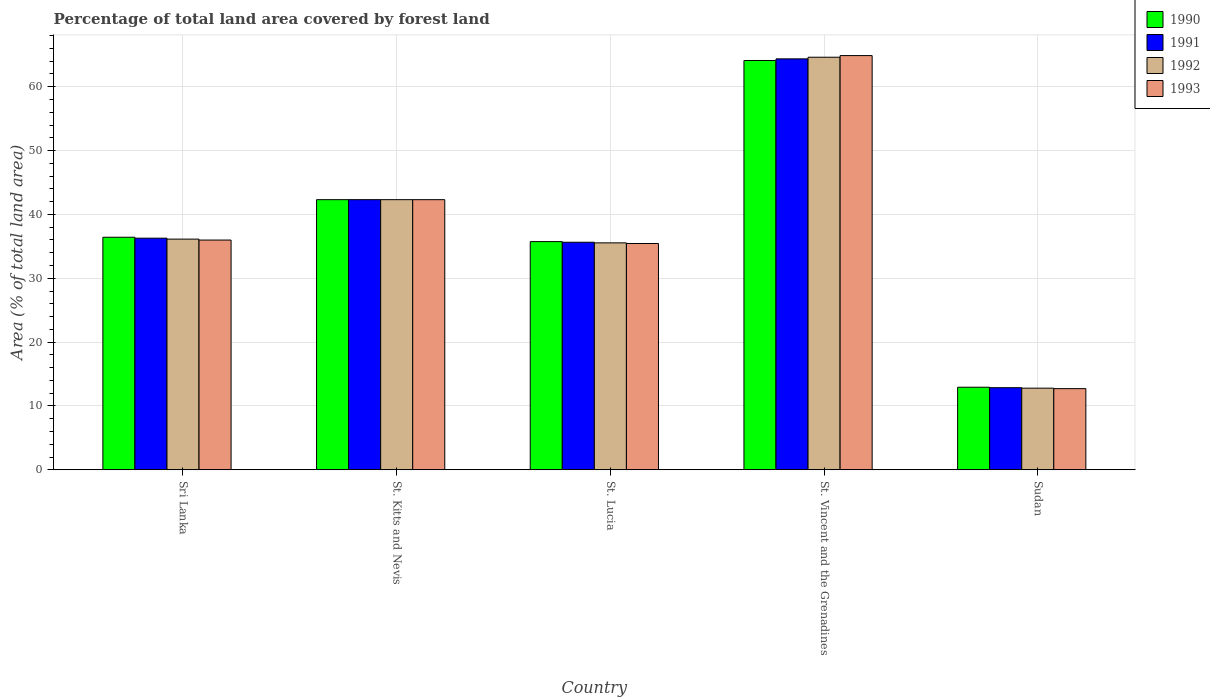How many different coloured bars are there?
Provide a short and direct response. 4. How many groups of bars are there?
Offer a very short reply. 5. What is the label of the 2nd group of bars from the left?
Provide a short and direct response. St. Kitts and Nevis. What is the percentage of forest land in 1992 in Sudan?
Ensure brevity in your answer.  12.79. Across all countries, what is the maximum percentage of forest land in 1991?
Provide a succinct answer. 64.36. Across all countries, what is the minimum percentage of forest land in 1992?
Your answer should be very brief. 12.79. In which country was the percentage of forest land in 1991 maximum?
Offer a very short reply. St. Vincent and the Grenadines. In which country was the percentage of forest land in 1990 minimum?
Offer a terse response. Sudan. What is the total percentage of forest land in 1993 in the graph?
Ensure brevity in your answer.  191.32. What is the difference between the percentage of forest land in 1991 in St. Lucia and that in Sudan?
Provide a short and direct response. 22.78. What is the difference between the percentage of forest land in 1992 in Sri Lanka and the percentage of forest land in 1993 in St. Kitts and Nevis?
Provide a succinct answer. -6.18. What is the average percentage of forest land in 1992 per country?
Make the answer very short. 38.28. What is the difference between the percentage of forest land of/in 1992 and percentage of forest land of/in 1991 in Sri Lanka?
Offer a very short reply. -0.15. In how many countries, is the percentage of forest land in 1990 greater than 56 %?
Ensure brevity in your answer.  1. What is the ratio of the percentage of forest land in 1992 in St. Vincent and the Grenadines to that in Sudan?
Keep it short and to the point. 5.05. Is the percentage of forest land in 1992 in St. Kitts and Nevis less than that in Sudan?
Keep it short and to the point. No. What is the difference between the highest and the second highest percentage of forest land in 1992?
Offer a very short reply. 22.31. What is the difference between the highest and the lowest percentage of forest land in 1992?
Provide a short and direct response. 51.83. In how many countries, is the percentage of forest land in 1991 greater than the average percentage of forest land in 1991 taken over all countries?
Ensure brevity in your answer.  2. Is it the case that in every country, the sum of the percentage of forest land in 1993 and percentage of forest land in 1992 is greater than the sum of percentage of forest land in 1990 and percentage of forest land in 1991?
Your answer should be compact. No. What does the 3rd bar from the left in Sudan represents?
Keep it short and to the point. 1992. What does the 2nd bar from the right in St. Lucia represents?
Your answer should be very brief. 1992. Is it the case that in every country, the sum of the percentage of forest land in 1991 and percentage of forest land in 1990 is greater than the percentage of forest land in 1993?
Keep it short and to the point. Yes. How many bars are there?
Offer a terse response. 20. Are all the bars in the graph horizontal?
Offer a terse response. No. Are the values on the major ticks of Y-axis written in scientific E-notation?
Your answer should be compact. No. Does the graph contain any zero values?
Offer a very short reply. No. Where does the legend appear in the graph?
Keep it short and to the point. Top right. How are the legend labels stacked?
Make the answer very short. Vertical. What is the title of the graph?
Provide a short and direct response. Percentage of total land area covered by forest land. What is the label or title of the Y-axis?
Your response must be concise. Area (% of total land area). What is the Area (% of total land area) in 1990 in Sri Lanka?
Your response must be concise. 36.42. What is the Area (% of total land area) in 1991 in Sri Lanka?
Give a very brief answer. 36.27. What is the Area (% of total land area) of 1992 in Sri Lanka?
Provide a succinct answer. 36.13. What is the Area (% of total land area) in 1993 in Sri Lanka?
Your answer should be compact. 35.98. What is the Area (% of total land area) in 1990 in St. Kitts and Nevis?
Offer a terse response. 42.31. What is the Area (% of total land area) of 1991 in St. Kitts and Nevis?
Ensure brevity in your answer.  42.31. What is the Area (% of total land area) in 1992 in St. Kitts and Nevis?
Provide a short and direct response. 42.31. What is the Area (% of total land area) in 1993 in St. Kitts and Nevis?
Provide a succinct answer. 42.31. What is the Area (% of total land area) in 1990 in St. Lucia?
Make the answer very short. 35.74. What is the Area (% of total land area) in 1991 in St. Lucia?
Make the answer very short. 35.64. What is the Area (% of total land area) of 1992 in St. Lucia?
Your answer should be compact. 35.54. What is the Area (% of total land area) in 1993 in St. Lucia?
Make the answer very short. 35.44. What is the Area (% of total land area) in 1990 in St. Vincent and the Grenadines?
Your response must be concise. 64.1. What is the Area (% of total land area) in 1991 in St. Vincent and the Grenadines?
Ensure brevity in your answer.  64.36. What is the Area (% of total land area) in 1992 in St. Vincent and the Grenadines?
Your response must be concise. 64.62. What is the Area (% of total land area) in 1993 in St. Vincent and the Grenadines?
Your answer should be very brief. 64.87. What is the Area (% of total land area) of 1990 in Sudan?
Provide a short and direct response. 12.93. What is the Area (% of total land area) in 1991 in Sudan?
Provide a succinct answer. 12.86. What is the Area (% of total land area) of 1992 in Sudan?
Give a very brief answer. 12.79. What is the Area (% of total land area) in 1993 in Sudan?
Offer a terse response. 12.71. Across all countries, what is the maximum Area (% of total land area) of 1990?
Your answer should be compact. 64.1. Across all countries, what is the maximum Area (% of total land area) in 1991?
Offer a very short reply. 64.36. Across all countries, what is the maximum Area (% of total land area) of 1992?
Keep it short and to the point. 64.62. Across all countries, what is the maximum Area (% of total land area) in 1993?
Ensure brevity in your answer.  64.87. Across all countries, what is the minimum Area (% of total land area) of 1990?
Offer a terse response. 12.93. Across all countries, what is the minimum Area (% of total land area) of 1991?
Provide a succinct answer. 12.86. Across all countries, what is the minimum Area (% of total land area) of 1992?
Your answer should be compact. 12.79. Across all countries, what is the minimum Area (% of total land area) of 1993?
Your answer should be compact. 12.71. What is the total Area (% of total land area) in 1990 in the graph?
Your answer should be very brief. 191.5. What is the total Area (% of total land area) in 1991 in the graph?
Your answer should be very brief. 191.44. What is the total Area (% of total land area) in 1992 in the graph?
Give a very brief answer. 191.38. What is the total Area (% of total land area) in 1993 in the graph?
Your answer should be compact. 191.32. What is the difference between the Area (% of total land area) of 1990 in Sri Lanka and that in St. Kitts and Nevis?
Keep it short and to the point. -5.89. What is the difference between the Area (% of total land area) of 1991 in Sri Lanka and that in St. Kitts and Nevis?
Your answer should be compact. -6.03. What is the difference between the Area (% of total land area) in 1992 in Sri Lanka and that in St. Kitts and Nevis?
Keep it short and to the point. -6.18. What is the difference between the Area (% of total land area) in 1993 in Sri Lanka and that in St. Kitts and Nevis?
Keep it short and to the point. -6.33. What is the difference between the Area (% of total land area) of 1990 in Sri Lanka and that in St. Lucia?
Ensure brevity in your answer.  0.68. What is the difference between the Area (% of total land area) of 1991 in Sri Lanka and that in St. Lucia?
Keep it short and to the point. 0.64. What is the difference between the Area (% of total land area) in 1992 in Sri Lanka and that in St. Lucia?
Your response must be concise. 0.59. What is the difference between the Area (% of total land area) in 1993 in Sri Lanka and that in St. Lucia?
Your answer should be very brief. 0.54. What is the difference between the Area (% of total land area) in 1990 in Sri Lanka and that in St. Vincent and the Grenadines?
Your response must be concise. -27.68. What is the difference between the Area (% of total land area) in 1991 in Sri Lanka and that in St. Vincent and the Grenadines?
Your answer should be very brief. -28.08. What is the difference between the Area (% of total land area) of 1992 in Sri Lanka and that in St. Vincent and the Grenadines?
Your answer should be compact. -28.49. What is the difference between the Area (% of total land area) in 1993 in Sri Lanka and that in St. Vincent and the Grenadines?
Give a very brief answer. -28.89. What is the difference between the Area (% of total land area) of 1990 in Sri Lanka and that in Sudan?
Your response must be concise. 23.49. What is the difference between the Area (% of total land area) of 1991 in Sri Lanka and that in Sudan?
Offer a very short reply. 23.42. What is the difference between the Area (% of total land area) in 1992 in Sri Lanka and that in Sudan?
Your answer should be very brief. 23.34. What is the difference between the Area (% of total land area) in 1993 in Sri Lanka and that in Sudan?
Offer a very short reply. 23.27. What is the difference between the Area (% of total land area) in 1990 in St. Kitts and Nevis and that in St. Lucia?
Your response must be concise. 6.57. What is the difference between the Area (% of total land area) in 1991 in St. Kitts and Nevis and that in St. Lucia?
Keep it short and to the point. 6.67. What is the difference between the Area (% of total land area) of 1992 in St. Kitts and Nevis and that in St. Lucia?
Provide a succinct answer. 6.77. What is the difference between the Area (% of total land area) in 1993 in St. Kitts and Nevis and that in St. Lucia?
Your response must be concise. 6.87. What is the difference between the Area (% of total land area) of 1990 in St. Kitts and Nevis and that in St. Vincent and the Grenadines?
Your response must be concise. -21.79. What is the difference between the Area (% of total land area) in 1991 in St. Kitts and Nevis and that in St. Vincent and the Grenadines?
Provide a short and direct response. -22.05. What is the difference between the Area (% of total land area) of 1992 in St. Kitts and Nevis and that in St. Vincent and the Grenadines?
Provide a short and direct response. -22.31. What is the difference between the Area (% of total land area) of 1993 in St. Kitts and Nevis and that in St. Vincent and the Grenadines?
Your answer should be very brief. -22.56. What is the difference between the Area (% of total land area) in 1990 in St. Kitts and Nevis and that in Sudan?
Your answer should be very brief. 29.38. What is the difference between the Area (% of total land area) in 1991 in St. Kitts and Nevis and that in Sudan?
Your answer should be compact. 29.45. What is the difference between the Area (% of total land area) of 1992 in St. Kitts and Nevis and that in Sudan?
Ensure brevity in your answer.  29.52. What is the difference between the Area (% of total land area) of 1993 in St. Kitts and Nevis and that in Sudan?
Ensure brevity in your answer.  29.6. What is the difference between the Area (% of total land area) in 1990 in St. Lucia and that in St. Vincent and the Grenadines?
Give a very brief answer. -28.36. What is the difference between the Area (% of total land area) in 1991 in St. Lucia and that in St. Vincent and the Grenadines?
Your answer should be compact. -28.72. What is the difference between the Area (% of total land area) of 1992 in St. Lucia and that in St. Vincent and the Grenadines?
Ensure brevity in your answer.  -29.07. What is the difference between the Area (% of total land area) in 1993 in St. Lucia and that in St. Vincent and the Grenadines?
Your response must be concise. -29.43. What is the difference between the Area (% of total land area) in 1990 in St. Lucia and that in Sudan?
Give a very brief answer. 22.81. What is the difference between the Area (% of total land area) of 1991 in St. Lucia and that in Sudan?
Give a very brief answer. 22.78. What is the difference between the Area (% of total land area) of 1992 in St. Lucia and that in Sudan?
Your response must be concise. 22.76. What is the difference between the Area (% of total land area) in 1993 in St. Lucia and that in Sudan?
Ensure brevity in your answer.  22.73. What is the difference between the Area (% of total land area) of 1990 in St. Vincent and the Grenadines and that in Sudan?
Make the answer very short. 51.17. What is the difference between the Area (% of total land area) in 1991 in St. Vincent and the Grenadines and that in Sudan?
Make the answer very short. 51.5. What is the difference between the Area (% of total land area) in 1992 in St. Vincent and the Grenadines and that in Sudan?
Offer a very short reply. 51.83. What is the difference between the Area (% of total land area) of 1993 in St. Vincent and the Grenadines and that in Sudan?
Keep it short and to the point. 52.16. What is the difference between the Area (% of total land area) in 1990 in Sri Lanka and the Area (% of total land area) in 1991 in St. Kitts and Nevis?
Make the answer very short. -5.89. What is the difference between the Area (% of total land area) of 1990 in Sri Lanka and the Area (% of total land area) of 1992 in St. Kitts and Nevis?
Your response must be concise. -5.89. What is the difference between the Area (% of total land area) in 1990 in Sri Lanka and the Area (% of total land area) in 1993 in St. Kitts and Nevis?
Your response must be concise. -5.89. What is the difference between the Area (% of total land area) of 1991 in Sri Lanka and the Area (% of total land area) of 1992 in St. Kitts and Nevis?
Your response must be concise. -6.03. What is the difference between the Area (% of total land area) of 1991 in Sri Lanka and the Area (% of total land area) of 1993 in St. Kitts and Nevis?
Your answer should be very brief. -6.03. What is the difference between the Area (% of total land area) in 1992 in Sri Lanka and the Area (% of total land area) in 1993 in St. Kitts and Nevis?
Provide a succinct answer. -6.18. What is the difference between the Area (% of total land area) in 1990 in Sri Lanka and the Area (% of total land area) in 1991 in St. Lucia?
Provide a short and direct response. 0.78. What is the difference between the Area (% of total land area) in 1990 in Sri Lanka and the Area (% of total land area) in 1992 in St. Lucia?
Provide a short and direct response. 0.88. What is the difference between the Area (% of total land area) in 1991 in Sri Lanka and the Area (% of total land area) in 1992 in St. Lucia?
Offer a very short reply. 0.73. What is the difference between the Area (% of total land area) in 1991 in Sri Lanka and the Area (% of total land area) in 1993 in St. Lucia?
Offer a very short reply. 0.83. What is the difference between the Area (% of total land area) of 1992 in Sri Lanka and the Area (% of total land area) of 1993 in St. Lucia?
Ensure brevity in your answer.  0.69. What is the difference between the Area (% of total land area) of 1990 in Sri Lanka and the Area (% of total land area) of 1991 in St. Vincent and the Grenadines?
Your response must be concise. -27.94. What is the difference between the Area (% of total land area) in 1990 in Sri Lanka and the Area (% of total land area) in 1992 in St. Vincent and the Grenadines?
Offer a terse response. -28.19. What is the difference between the Area (% of total land area) of 1990 in Sri Lanka and the Area (% of total land area) of 1993 in St. Vincent and the Grenadines?
Your answer should be compact. -28.45. What is the difference between the Area (% of total land area) in 1991 in Sri Lanka and the Area (% of total land area) in 1992 in St. Vincent and the Grenadines?
Offer a terse response. -28.34. What is the difference between the Area (% of total land area) in 1991 in Sri Lanka and the Area (% of total land area) in 1993 in St. Vincent and the Grenadines?
Ensure brevity in your answer.  -28.6. What is the difference between the Area (% of total land area) of 1992 in Sri Lanka and the Area (% of total land area) of 1993 in St. Vincent and the Grenadines?
Keep it short and to the point. -28.74. What is the difference between the Area (% of total land area) of 1990 in Sri Lanka and the Area (% of total land area) of 1991 in Sudan?
Your answer should be very brief. 23.56. What is the difference between the Area (% of total land area) of 1990 in Sri Lanka and the Area (% of total land area) of 1992 in Sudan?
Keep it short and to the point. 23.64. What is the difference between the Area (% of total land area) of 1990 in Sri Lanka and the Area (% of total land area) of 1993 in Sudan?
Keep it short and to the point. 23.71. What is the difference between the Area (% of total land area) in 1991 in Sri Lanka and the Area (% of total land area) in 1992 in Sudan?
Keep it short and to the point. 23.49. What is the difference between the Area (% of total land area) in 1991 in Sri Lanka and the Area (% of total land area) in 1993 in Sudan?
Offer a terse response. 23.56. What is the difference between the Area (% of total land area) of 1992 in Sri Lanka and the Area (% of total land area) of 1993 in Sudan?
Keep it short and to the point. 23.42. What is the difference between the Area (% of total land area) in 1990 in St. Kitts and Nevis and the Area (% of total land area) in 1991 in St. Lucia?
Give a very brief answer. 6.67. What is the difference between the Area (% of total land area) in 1990 in St. Kitts and Nevis and the Area (% of total land area) in 1992 in St. Lucia?
Your response must be concise. 6.77. What is the difference between the Area (% of total land area) in 1990 in St. Kitts and Nevis and the Area (% of total land area) in 1993 in St. Lucia?
Provide a short and direct response. 6.87. What is the difference between the Area (% of total land area) of 1991 in St. Kitts and Nevis and the Area (% of total land area) of 1992 in St. Lucia?
Offer a terse response. 6.77. What is the difference between the Area (% of total land area) of 1991 in St. Kitts and Nevis and the Area (% of total land area) of 1993 in St. Lucia?
Make the answer very short. 6.87. What is the difference between the Area (% of total land area) in 1992 in St. Kitts and Nevis and the Area (% of total land area) in 1993 in St. Lucia?
Offer a very short reply. 6.87. What is the difference between the Area (% of total land area) of 1990 in St. Kitts and Nevis and the Area (% of total land area) of 1991 in St. Vincent and the Grenadines?
Provide a succinct answer. -22.05. What is the difference between the Area (% of total land area) of 1990 in St. Kitts and Nevis and the Area (% of total land area) of 1992 in St. Vincent and the Grenadines?
Offer a terse response. -22.31. What is the difference between the Area (% of total land area) in 1990 in St. Kitts and Nevis and the Area (% of total land area) in 1993 in St. Vincent and the Grenadines?
Make the answer very short. -22.56. What is the difference between the Area (% of total land area) of 1991 in St. Kitts and Nevis and the Area (% of total land area) of 1992 in St. Vincent and the Grenadines?
Offer a terse response. -22.31. What is the difference between the Area (% of total land area) of 1991 in St. Kitts and Nevis and the Area (% of total land area) of 1993 in St. Vincent and the Grenadines?
Your answer should be very brief. -22.56. What is the difference between the Area (% of total land area) of 1992 in St. Kitts and Nevis and the Area (% of total land area) of 1993 in St. Vincent and the Grenadines?
Offer a very short reply. -22.56. What is the difference between the Area (% of total land area) of 1990 in St. Kitts and Nevis and the Area (% of total land area) of 1991 in Sudan?
Make the answer very short. 29.45. What is the difference between the Area (% of total land area) of 1990 in St. Kitts and Nevis and the Area (% of total land area) of 1992 in Sudan?
Ensure brevity in your answer.  29.52. What is the difference between the Area (% of total land area) in 1990 in St. Kitts and Nevis and the Area (% of total land area) in 1993 in Sudan?
Make the answer very short. 29.6. What is the difference between the Area (% of total land area) in 1991 in St. Kitts and Nevis and the Area (% of total land area) in 1992 in Sudan?
Offer a terse response. 29.52. What is the difference between the Area (% of total land area) in 1991 in St. Kitts and Nevis and the Area (% of total land area) in 1993 in Sudan?
Ensure brevity in your answer.  29.6. What is the difference between the Area (% of total land area) in 1992 in St. Kitts and Nevis and the Area (% of total land area) in 1993 in Sudan?
Give a very brief answer. 29.6. What is the difference between the Area (% of total land area) of 1990 in St. Lucia and the Area (% of total land area) of 1991 in St. Vincent and the Grenadines?
Keep it short and to the point. -28.62. What is the difference between the Area (% of total land area) in 1990 in St. Lucia and the Area (% of total land area) in 1992 in St. Vincent and the Grenadines?
Your response must be concise. -28.88. What is the difference between the Area (% of total land area) in 1990 in St. Lucia and the Area (% of total land area) in 1993 in St. Vincent and the Grenadines?
Provide a succinct answer. -29.13. What is the difference between the Area (% of total land area) of 1991 in St. Lucia and the Area (% of total land area) of 1992 in St. Vincent and the Grenadines?
Make the answer very short. -28.98. What is the difference between the Area (% of total land area) in 1991 in St. Lucia and the Area (% of total land area) in 1993 in St. Vincent and the Grenadines?
Your answer should be compact. -29.23. What is the difference between the Area (% of total land area) in 1992 in St. Lucia and the Area (% of total land area) in 1993 in St. Vincent and the Grenadines?
Your answer should be compact. -29.33. What is the difference between the Area (% of total land area) of 1990 in St. Lucia and the Area (% of total land area) of 1991 in Sudan?
Keep it short and to the point. 22.88. What is the difference between the Area (% of total land area) of 1990 in St. Lucia and the Area (% of total land area) of 1992 in Sudan?
Make the answer very short. 22.95. What is the difference between the Area (% of total land area) of 1990 in St. Lucia and the Area (% of total land area) of 1993 in Sudan?
Make the answer very short. 23.03. What is the difference between the Area (% of total land area) of 1991 in St. Lucia and the Area (% of total land area) of 1992 in Sudan?
Keep it short and to the point. 22.85. What is the difference between the Area (% of total land area) in 1991 in St. Lucia and the Area (% of total land area) in 1993 in Sudan?
Offer a terse response. 22.93. What is the difference between the Area (% of total land area) in 1992 in St. Lucia and the Area (% of total land area) in 1993 in Sudan?
Your answer should be compact. 22.83. What is the difference between the Area (% of total land area) of 1990 in St. Vincent and the Grenadines and the Area (% of total land area) of 1991 in Sudan?
Your response must be concise. 51.24. What is the difference between the Area (% of total land area) in 1990 in St. Vincent and the Grenadines and the Area (% of total land area) in 1992 in Sudan?
Provide a short and direct response. 51.32. What is the difference between the Area (% of total land area) of 1990 in St. Vincent and the Grenadines and the Area (% of total land area) of 1993 in Sudan?
Provide a succinct answer. 51.39. What is the difference between the Area (% of total land area) in 1991 in St. Vincent and the Grenadines and the Area (% of total land area) in 1992 in Sudan?
Provide a succinct answer. 51.57. What is the difference between the Area (% of total land area) of 1991 in St. Vincent and the Grenadines and the Area (% of total land area) of 1993 in Sudan?
Give a very brief answer. 51.65. What is the difference between the Area (% of total land area) in 1992 in St. Vincent and the Grenadines and the Area (% of total land area) in 1993 in Sudan?
Provide a succinct answer. 51.9. What is the average Area (% of total land area) in 1990 per country?
Provide a short and direct response. 38.3. What is the average Area (% of total land area) in 1991 per country?
Give a very brief answer. 38.29. What is the average Area (% of total land area) in 1992 per country?
Offer a terse response. 38.28. What is the average Area (% of total land area) in 1993 per country?
Provide a succinct answer. 38.26. What is the difference between the Area (% of total land area) in 1990 and Area (% of total land area) in 1991 in Sri Lanka?
Your answer should be very brief. 0.15. What is the difference between the Area (% of total land area) of 1990 and Area (% of total land area) of 1992 in Sri Lanka?
Ensure brevity in your answer.  0.29. What is the difference between the Area (% of total land area) of 1990 and Area (% of total land area) of 1993 in Sri Lanka?
Keep it short and to the point. 0.44. What is the difference between the Area (% of total land area) in 1991 and Area (% of total land area) in 1992 in Sri Lanka?
Provide a succinct answer. 0.15. What is the difference between the Area (% of total land area) in 1991 and Area (% of total land area) in 1993 in Sri Lanka?
Your answer should be very brief. 0.29. What is the difference between the Area (% of total land area) in 1992 and Area (% of total land area) in 1993 in Sri Lanka?
Keep it short and to the point. 0.15. What is the difference between the Area (% of total land area) in 1990 and Area (% of total land area) in 1991 in St. Kitts and Nevis?
Your response must be concise. 0. What is the difference between the Area (% of total land area) in 1991 and Area (% of total land area) in 1992 in St. Kitts and Nevis?
Offer a very short reply. 0. What is the difference between the Area (% of total land area) of 1990 and Area (% of total land area) of 1991 in St. Lucia?
Ensure brevity in your answer.  0.1. What is the difference between the Area (% of total land area) of 1990 and Area (% of total land area) of 1992 in St. Lucia?
Give a very brief answer. 0.2. What is the difference between the Area (% of total land area) in 1990 and Area (% of total land area) in 1993 in St. Lucia?
Offer a very short reply. 0.3. What is the difference between the Area (% of total land area) of 1991 and Area (% of total land area) of 1992 in St. Lucia?
Offer a very short reply. 0.1. What is the difference between the Area (% of total land area) of 1991 and Area (% of total land area) of 1993 in St. Lucia?
Your response must be concise. 0.2. What is the difference between the Area (% of total land area) in 1992 and Area (% of total land area) in 1993 in St. Lucia?
Offer a very short reply. 0.1. What is the difference between the Area (% of total land area) in 1990 and Area (% of total land area) in 1991 in St. Vincent and the Grenadines?
Your response must be concise. -0.26. What is the difference between the Area (% of total land area) of 1990 and Area (% of total land area) of 1992 in St. Vincent and the Grenadines?
Provide a succinct answer. -0.51. What is the difference between the Area (% of total land area) in 1990 and Area (% of total land area) in 1993 in St. Vincent and the Grenadines?
Provide a succinct answer. -0.77. What is the difference between the Area (% of total land area) in 1991 and Area (% of total land area) in 1992 in St. Vincent and the Grenadines?
Make the answer very short. -0.26. What is the difference between the Area (% of total land area) of 1991 and Area (% of total land area) of 1993 in St. Vincent and the Grenadines?
Your response must be concise. -0.51. What is the difference between the Area (% of total land area) in 1992 and Area (% of total land area) in 1993 in St. Vincent and the Grenadines?
Make the answer very short. -0.26. What is the difference between the Area (% of total land area) of 1990 and Area (% of total land area) of 1991 in Sudan?
Provide a succinct answer. 0.07. What is the difference between the Area (% of total land area) in 1990 and Area (% of total land area) in 1992 in Sudan?
Your answer should be compact. 0.15. What is the difference between the Area (% of total land area) of 1990 and Area (% of total land area) of 1993 in Sudan?
Offer a terse response. 0.22. What is the difference between the Area (% of total land area) of 1991 and Area (% of total land area) of 1992 in Sudan?
Provide a short and direct response. 0.07. What is the difference between the Area (% of total land area) of 1991 and Area (% of total land area) of 1993 in Sudan?
Offer a very short reply. 0.15. What is the difference between the Area (% of total land area) in 1992 and Area (% of total land area) in 1993 in Sudan?
Offer a very short reply. 0.07. What is the ratio of the Area (% of total land area) of 1990 in Sri Lanka to that in St. Kitts and Nevis?
Offer a very short reply. 0.86. What is the ratio of the Area (% of total land area) in 1991 in Sri Lanka to that in St. Kitts and Nevis?
Offer a very short reply. 0.86. What is the ratio of the Area (% of total land area) in 1992 in Sri Lanka to that in St. Kitts and Nevis?
Offer a terse response. 0.85. What is the ratio of the Area (% of total land area) in 1993 in Sri Lanka to that in St. Kitts and Nevis?
Offer a terse response. 0.85. What is the ratio of the Area (% of total land area) in 1990 in Sri Lanka to that in St. Lucia?
Your answer should be compact. 1.02. What is the ratio of the Area (% of total land area) in 1991 in Sri Lanka to that in St. Lucia?
Offer a terse response. 1.02. What is the ratio of the Area (% of total land area) of 1992 in Sri Lanka to that in St. Lucia?
Offer a terse response. 1.02. What is the ratio of the Area (% of total land area) of 1993 in Sri Lanka to that in St. Lucia?
Make the answer very short. 1.02. What is the ratio of the Area (% of total land area) in 1990 in Sri Lanka to that in St. Vincent and the Grenadines?
Provide a short and direct response. 0.57. What is the ratio of the Area (% of total land area) of 1991 in Sri Lanka to that in St. Vincent and the Grenadines?
Offer a very short reply. 0.56. What is the ratio of the Area (% of total land area) in 1992 in Sri Lanka to that in St. Vincent and the Grenadines?
Your answer should be very brief. 0.56. What is the ratio of the Area (% of total land area) of 1993 in Sri Lanka to that in St. Vincent and the Grenadines?
Your response must be concise. 0.55. What is the ratio of the Area (% of total land area) of 1990 in Sri Lanka to that in Sudan?
Ensure brevity in your answer.  2.82. What is the ratio of the Area (% of total land area) in 1991 in Sri Lanka to that in Sudan?
Ensure brevity in your answer.  2.82. What is the ratio of the Area (% of total land area) in 1992 in Sri Lanka to that in Sudan?
Make the answer very short. 2.83. What is the ratio of the Area (% of total land area) in 1993 in Sri Lanka to that in Sudan?
Offer a terse response. 2.83. What is the ratio of the Area (% of total land area) of 1990 in St. Kitts and Nevis to that in St. Lucia?
Ensure brevity in your answer.  1.18. What is the ratio of the Area (% of total land area) in 1991 in St. Kitts and Nevis to that in St. Lucia?
Provide a short and direct response. 1.19. What is the ratio of the Area (% of total land area) in 1992 in St. Kitts and Nevis to that in St. Lucia?
Offer a very short reply. 1.19. What is the ratio of the Area (% of total land area) of 1993 in St. Kitts and Nevis to that in St. Lucia?
Give a very brief answer. 1.19. What is the ratio of the Area (% of total land area) in 1990 in St. Kitts and Nevis to that in St. Vincent and the Grenadines?
Offer a very short reply. 0.66. What is the ratio of the Area (% of total land area) in 1991 in St. Kitts and Nevis to that in St. Vincent and the Grenadines?
Your answer should be very brief. 0.66. What is the ratio of the Area (% of total land area) of 1992 in St. Kitts and Nevis to that in St. Vincent and the Grenadines?
Your response must be concise. 0.65. What is the ratio of the Area (% of total land area) in 1993 in St. Kitts and Nevis to that in St. Vincent and the Grenadines?
Keep it short and to the point. 0.65. What is the ratio of the Area (% of total land area) in 1990 in St. Kitts and Nevis to that in Sudan?
Offer a very short reply. 3.27. What is the ratio of the Area (% of total land area) of 1991 in St. Kitts and Nevis to that in Sudan?
Make the answer very short. 3.29. What is the ratio of the Area (% of total land area) in 1992 in St. Kitts and Nevis to that in Sudan?
Provide a succinct answer. 3.31. What is the ratio of the Area (% of total land area) of 1993 in St. Kitts and Nevis to that in Sudan?
Ensure brevity in your answer.  3.33. What is the ratio of the Area (% of total land area) of 1990 in St. Lucia to that in St. Vincent and the Grenadines?
Provide a short and direct response. 0.56. What is the ratio of the Area (% of total land area) of 1991 in St. Lucia to that in St. Vincent and the Grenadines?
Make the answer very short. 0.55. What is the ratio of the Area (% of total land area) of 1992 in St. Lucia to that in St. Vincent and the Grenadines?
Offer a very short reply. 0.55. What is the ratio of the Area (% of total land area) in 1993 in St. Lucia to that in St. Vincent and the Grenadines?
Provide a succinct answer. 0.55. What is the ratio of the Area (% of total land area) in 1990 in St. Lucia to that in Sudan?
Your answer should be compact. 2.76. What is the ratio of the Area (% of total land area) in 1991 in St. Lucia to that in Sudan?
Your answer should be compact. 2.77. What is the ratio of the Area (% of total land area) of 1992 in St. Lucia to that in Sudan?
Give a very brief answer. 2.78. What is the ratio of the Area (% of total land area) in 1993 in St. Lucia to that in Sudan?
Offer a terse response. 2.79. What is the ratio of the Area (% of total land area) in 1990 in St. Vincent and the Grenadines to that in Sudan?
Ensure brevity in your answer.  4.96. What is the ratio of the Area (% of total land area) of 1991 in St. Vincent and the Grenadines to that in Sudan?
Your answer should be very brief. 5. What is the ratio of the Area (% of total land area) of 1992 in St. Vincent and the Grenadines to that in Sudan?
Your answer should be very brief. 5.05. What is the ratio of the Area (% of total land area) of 1993 in St. Vincent and the Grenadines to that in Sudan?
Your response must be concise. 5.1. What is the difference between the highest and the second highest Area (% of total land area) in 1990?
Your answer should be very brief. 21.79. What is the difference between the highest and the second highest Area (% of total land area) of 1991?
Your answer should be very brief. 22.05. What is the difference between the highest and the second highest Area (% of total land area) of 1992?
Your answer should be very brief. 22.31. What is the difference between the highest and the second highest Area (% of total land area) in 1993?
Provide a succinct answer. 22.56. What is the difference between the highest and the lowest Area (% of total land area) in 1990?
Your answer should be very brief. 51.17. What is the difference between the highest and the lowest Area (% of total land area) of 1991?
Provide a succinct answer. 51.5. What is the difference between the highest and the lowest Area (% of total land area) in 1992?
Your response must be concise. 51.83. What is the difference between the highest and the lowest Area (% of total land area) of 1993?
Your response must be concise. 52.16. 